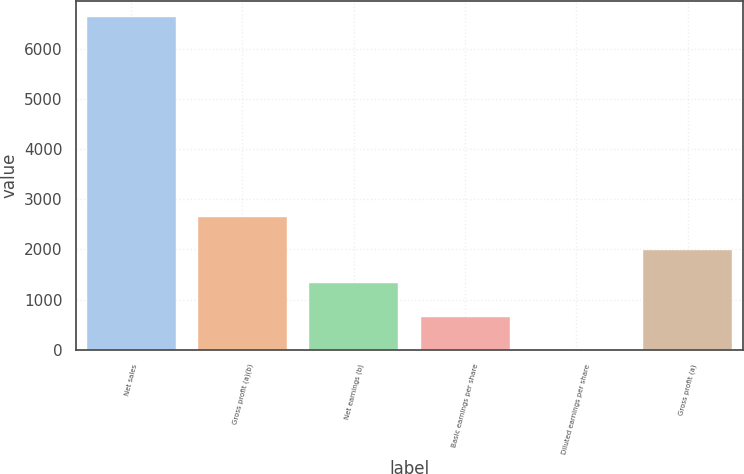Convert chart to OTSL. <chart><loc_0><loc_0><loc_500><loc_500><bar_chart><fcel>Net sales<fcel>Gross profit (a)(b)<fcel>Net earnings (b)<fcel>Basic earnings per share<fcel>Diluted earnings per share<fcel>Gross profit (a)<nl><fcel>6621.5<fcel>2650.5<fcel>1326.82<fcel>664.98<fcel>3.14<fcel>1988.66<nl></chart> 